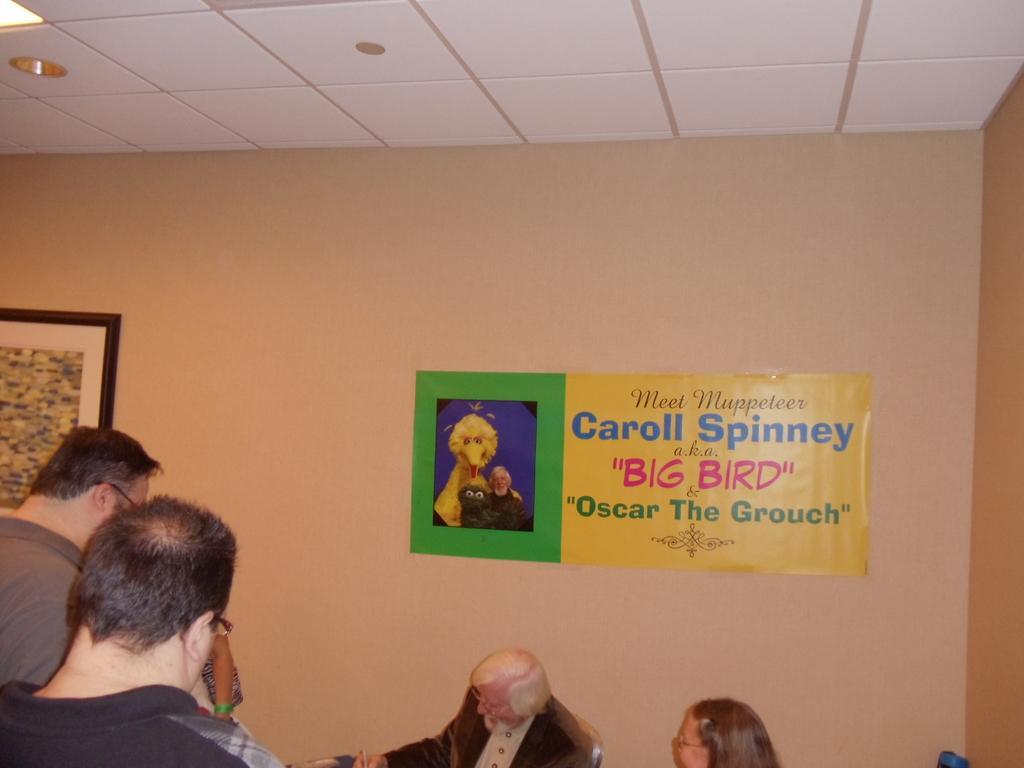How would you summarize this image in a sentence or two? In this image we can see a person is sitting and writing something. To the left bottom of the image few persons are standing and the wall of the room is in brown color. On wall one frame and poster is attached. The roof is in white color. 